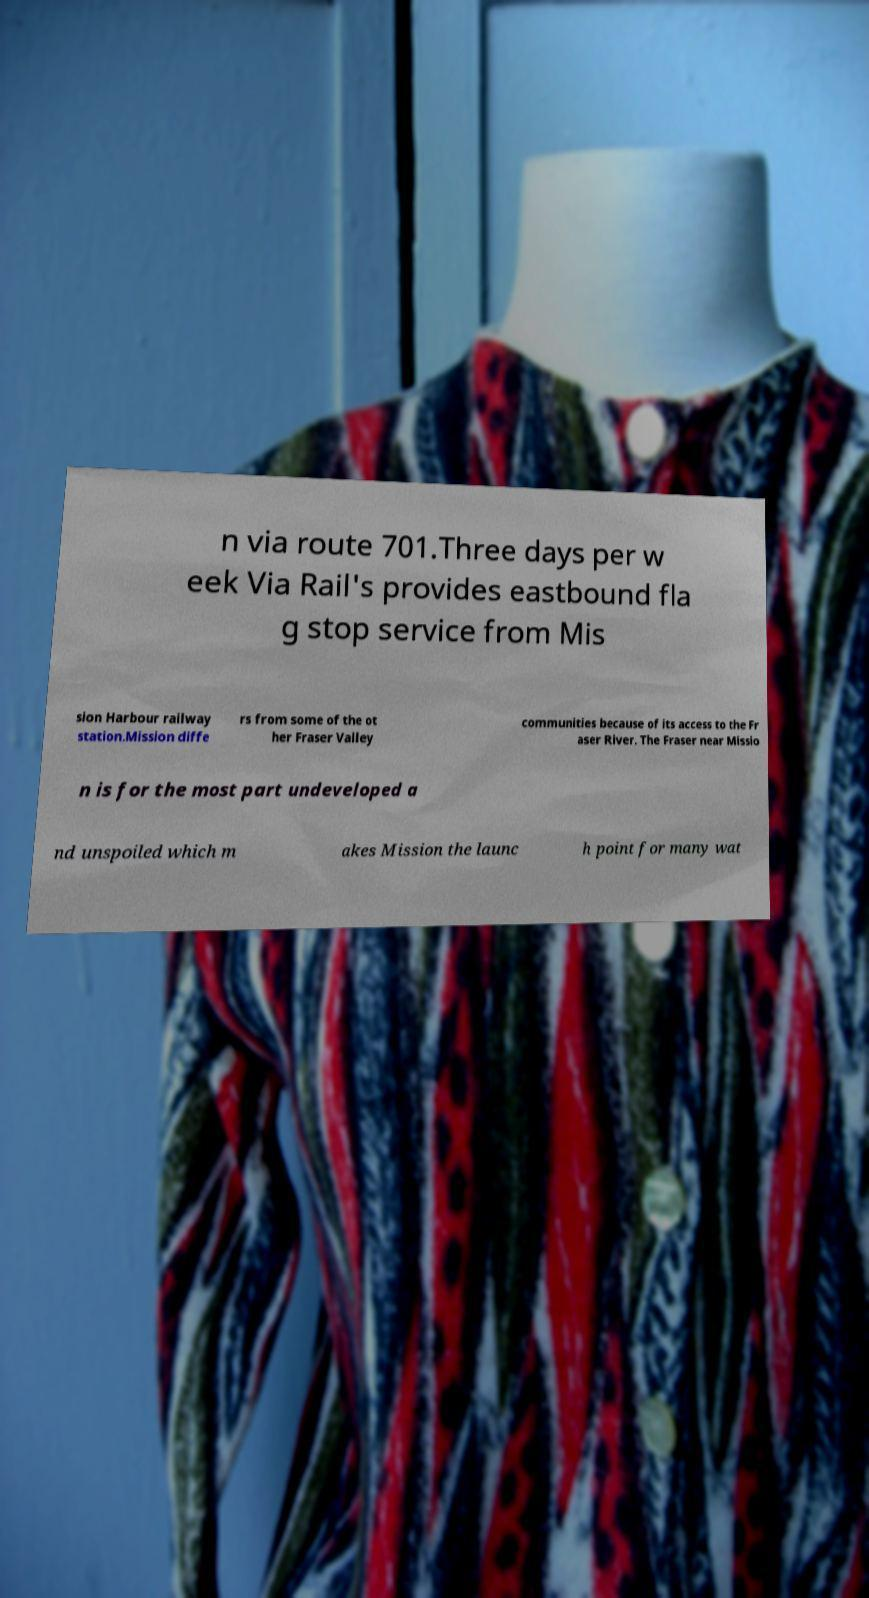Please identify and transcribe the text found in this image. n via route 701.Three days per w eek Via Rail's provides eastbound fla g stop service from Mis sion Harbour railway station.Mission diffe rs from some of the ot her Fraser Valley communities because of its access to the Fr aser River. The Fraser near Missio n is for the most part undeveloped a nd unspoiled which m akes Mission the launc h point for many wat 